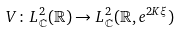<formula> <loc_0><loc_0><loc_500><loc_500>V \colon L ^ { 2 } _ { \mathbb { C } } ( \mathbb { R } ) \rightarrow L ^ { 2 } _ { \mathbb { C } } ( \mathbb { R } , e ^ { 2 K \xi } )</formula> 